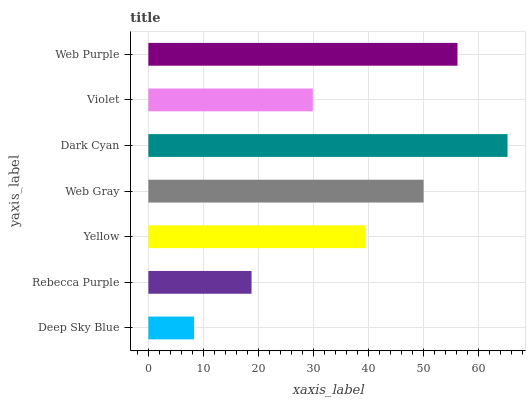Is Deep Sky Blue the minimum?
Answer yes or no. Yes. Is Dark Cyan the maximum?
Answer yes or no. Yes. Is Rebecca Purple the minimum?
Answer yes or no. No. Is Rebecca Purple the maximum?
Answer yes or no. No. Is Rebecca Purple greater than Deep Sky Blue?
Answer yes or no. Yes. Is Deep Sky Blue less than Rebecca Purple?
Answer yes or no. Yes. Is Deep Sky Blue greater than Rebecca Purple?
Answer yes or no. No. Is Rebecca Purple less than Deep Sky Blue?
Answer yes or no. No. Is Yellow the high median?
Answer yes or no. Yes. Is Yellow the low median?
Answer yes or no. Yes. Is Rebecca Purple the high median?
Answer yes or no. No. Is Violet the low median?
Answer yes or no. No. 